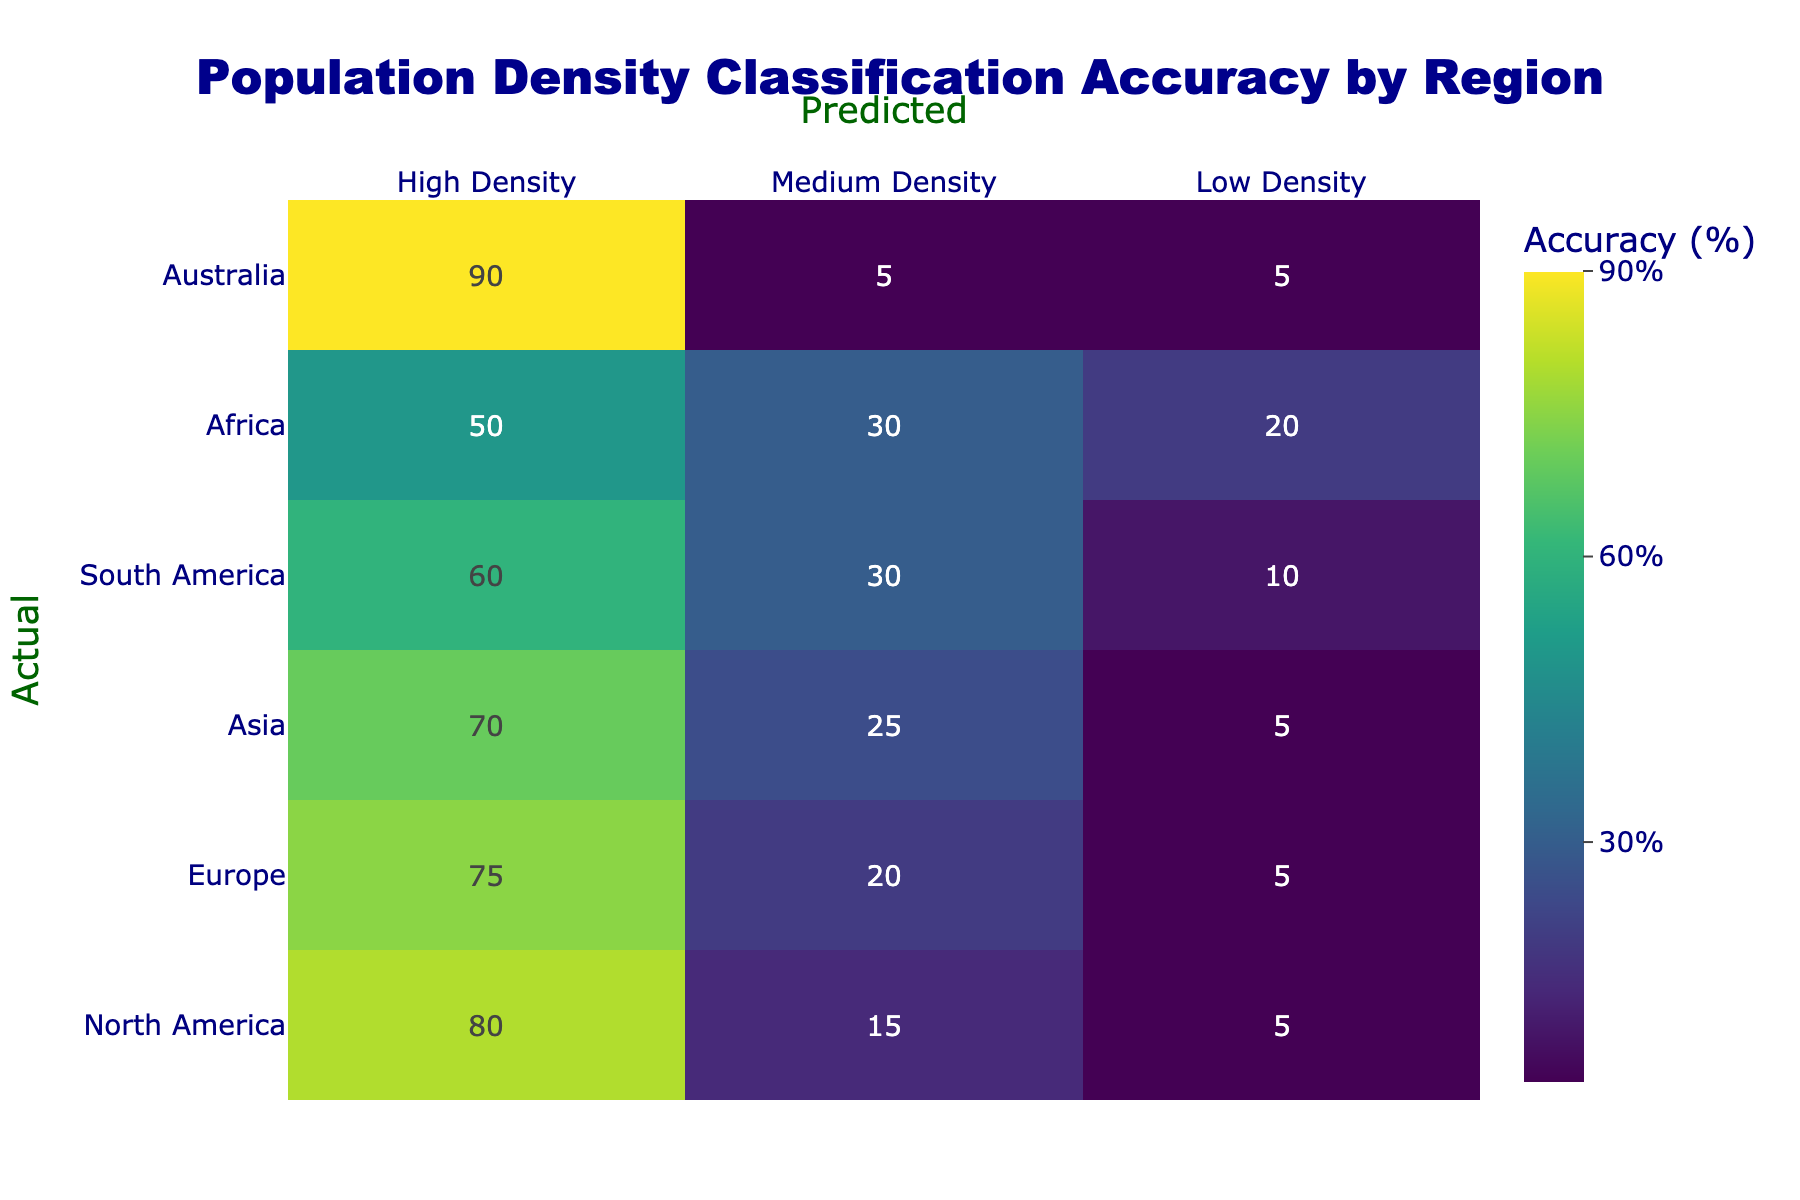What is the population density classification accuracy for North America in the High Density category? According to the table, North America has an accuracy of 80% for the High Density classification.
Answer: 80% Which region has the highest accuracy in predicting Low Density populations? By examining the Low Density column, Africa has the highest accuracy at 20%.
Answer: 20% What is the total accuracy for Medium Density across all regions? To find the total accuracy for Medium Density, we sum the values in the Medium Density column: 15 + 20 + 25 + 30 + 30 + 5 = 125.
Answer: 125 Is it true that Asia has a higher accuracy in Medium Density compared to Africa? Yes, Asia has an accuracy of 25% for Medium Density, while Africa has an accuracy of 30%. Thus, Asia does not have a higher accuracy than Africa.
Answer: No What is the average accuracy for High Density across the regions? We calculate the average accuracy by summing the High Density values (80 + 75 + 70 + 60 + 50 + 90 = 425) and dividing by the number of regions (6). The average is 425 / 6 = 70.83%.
Answer: 70.83% 